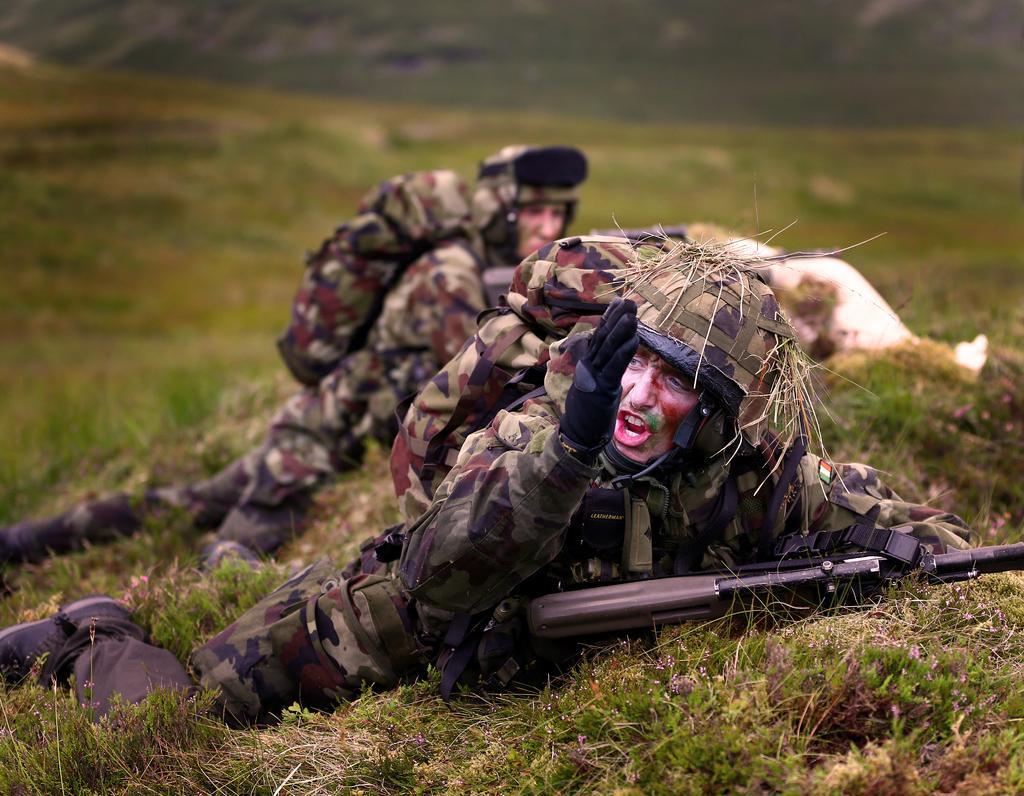How would you summarize this image in a sentence or two? In this image we can see there are people lying on the ground and holding a gun. And there is a grass. At the back it looks like a blur. 